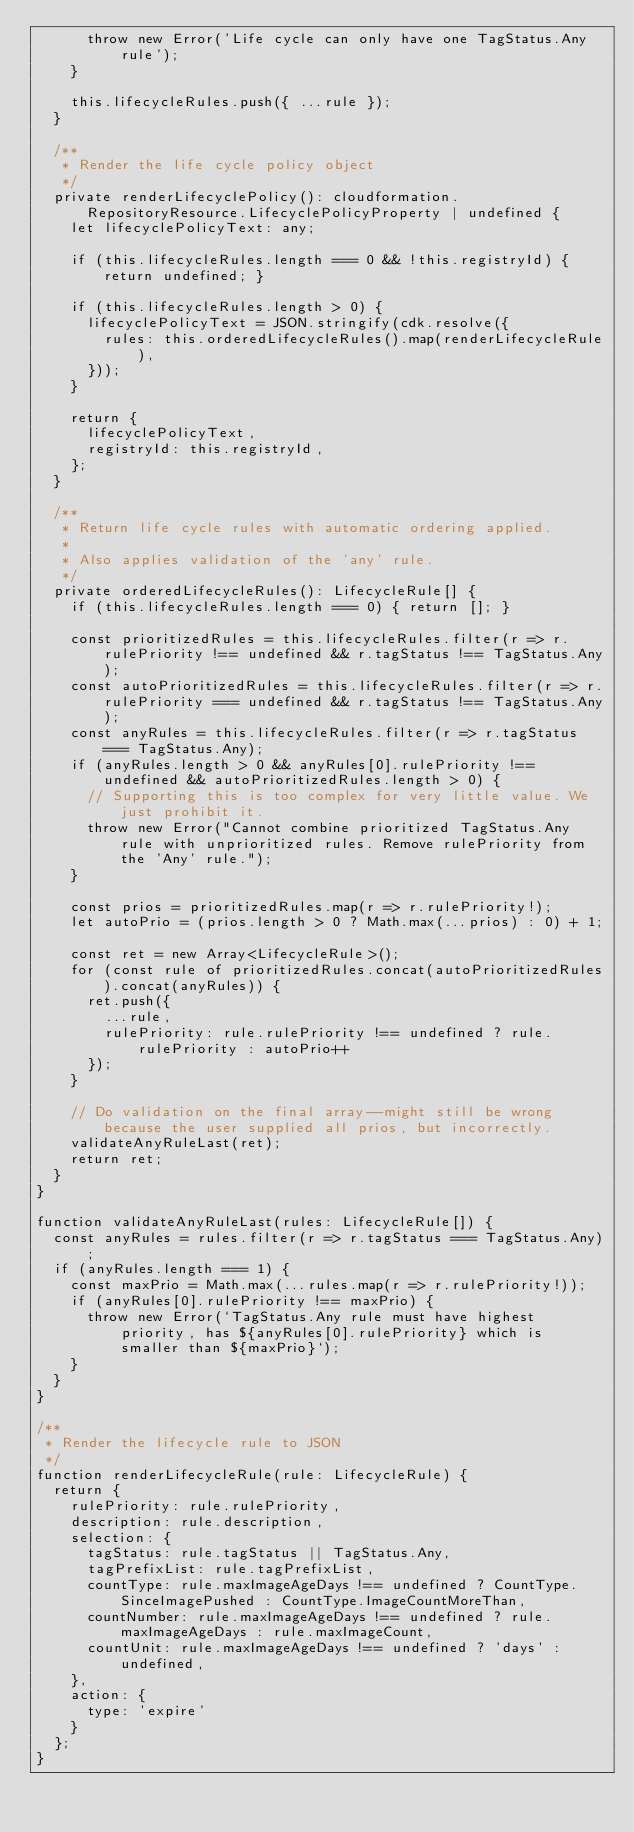Convert code to text. <code><loc_0><loc_0><loc_500><loc_500><_TypeScript_>      throw new Error('Life cycle can only have one TagStatus.Any rule');
    }

    this.lifecycleRules.push({ ...rule });
  }

  /**
   * Render the life cycle policy object
   */
  private renderLifecyclePolicy(): cloudformation.RepositoryResource.LifecyclePolicyProperty | undefined {
    let lifecyclePolicyText: any;

    if (this.lifecycleRules.length === 0 && !this.registryId) { return undefined; }

    if (this.lifecycleRules.length > 0) {
      lifecyclePolicyText = JSON.stringify(cdk.resolve({
        rules: this.orderedLifecycleRules().map(renderLifecycleRule),
      }));
    }

    return {
      lifecyclePolicyText,
      registryId: this.registryId,
    };
  }

  /**
   * Return life cycle rules with automatic ordering applied.
   *
   * Also applies validation of the 'any' rule.
   */
  private orderedLifecycleRules(): LifecycleRule[] {
    if (this.lifecycleRules.length === 0) { return []; }

    const prioritizedRules = this.lifecycleRules.filter(r => r.rulePriority !== undefined && r.tagStatus !== TagStatus.Any);
    const autoPrioritizedRules = this.lifecycleRules.filter(r => r.rulePriority === undefined && r.tagStatus !== TagStatus.Any);
    const anyRules = this.lifecycleRules.filter(r => r.tagStatus === TagStatus.Any);
    if (anyRules.length > 0 && anyRules[0].rulePriority !== undefined && autoPrioritizedRules.length > 0) {
      // Supporting this is too complex for very little value. We just prohibit it.
      throw new Error("Cannot combine prioritized TagStatus.Any rule with unprioritized rules. Remove rulePriority from the 'Any' rule.");
    }

    const prios = prioritizedRules.map(r => r.rulePriority!);
    let autoPrio = (prios.length > 0 ? Math.max(...prios) : 0) + 1;

    const ret = new Array<LifecycleRule>();
    for (const rule of prioritizedRules.concat(autoPrioritizedRules).concat(anyRules)) {
      ret.push({
        ...rule,
        rulePriority: rule.rulePriority !== undefined ? rule.rulePriority : autoPrio++
      });
    }

    // Do validation on the final array--might still be wrong because the user supplied all prios, but incorrectly.
    validateAnyRuleLast(ret);
    return ret;
  }
}

function validateAnyRuleLast(rules: LifecycleRule[]) {
  const anyRules = rules.filter(r => r.tagStatus === TagStatus.Any);
  if (anyRules.length === 1) {
    const maxPrio = Math.max(...rules.map(r => r.rulePriority!));
    if (anyRules[0].rulePriority !== maxPrio) {
      throw new Error(`TagStatus.Any rule must have highest priority, has ${anyRules[0].rulePriority} which is smaller than ${maxPrio}`);
    }
  }
}

/**
 * Render the lifecycle rule to JSON
 */
function renderLifecycleRule(rule: LifecycleRule) {
  return {
    rulePriority: rule.rulePriority,
    description: rule.description,
    selection: {
      tagStatus: rule.tagStatus || TagStatus.Any,
      tagPrefixList: rule.tagPrefixList,
      countType: rule.maxImageAgeDays !== undefined ? CountType.SinceImagePushed : CountType.ImageCountMoreThan,
      countNumber: rule.maxImageAgeDays !== undefined ? rule.maxImageAgeDays : rule.maxImageCount,
      countUnit: rule.maxImageAgeDays !== undefined ? 'days' : undefined,
    },
    action: {
      type: 'expire'
    }
  };
}
</code> 